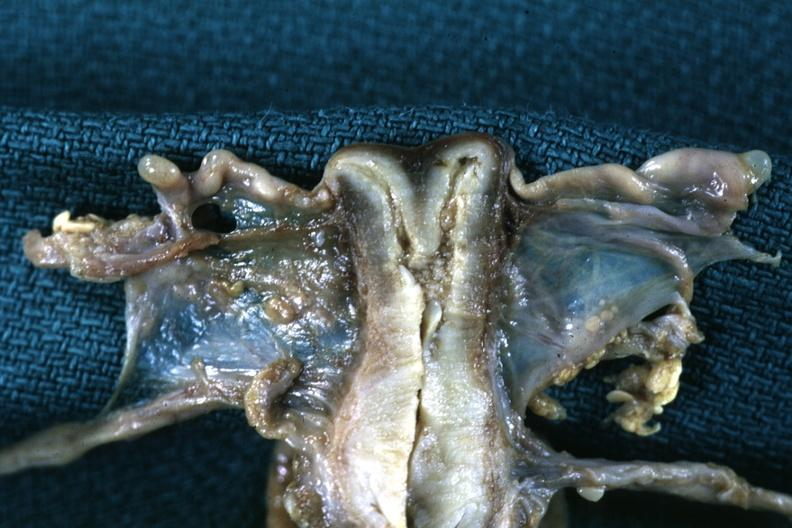does this image show fixed tissue frontal section single fundus duplicated endocervix and exocervix?
Answer the question using a single word or phrase. Yes 